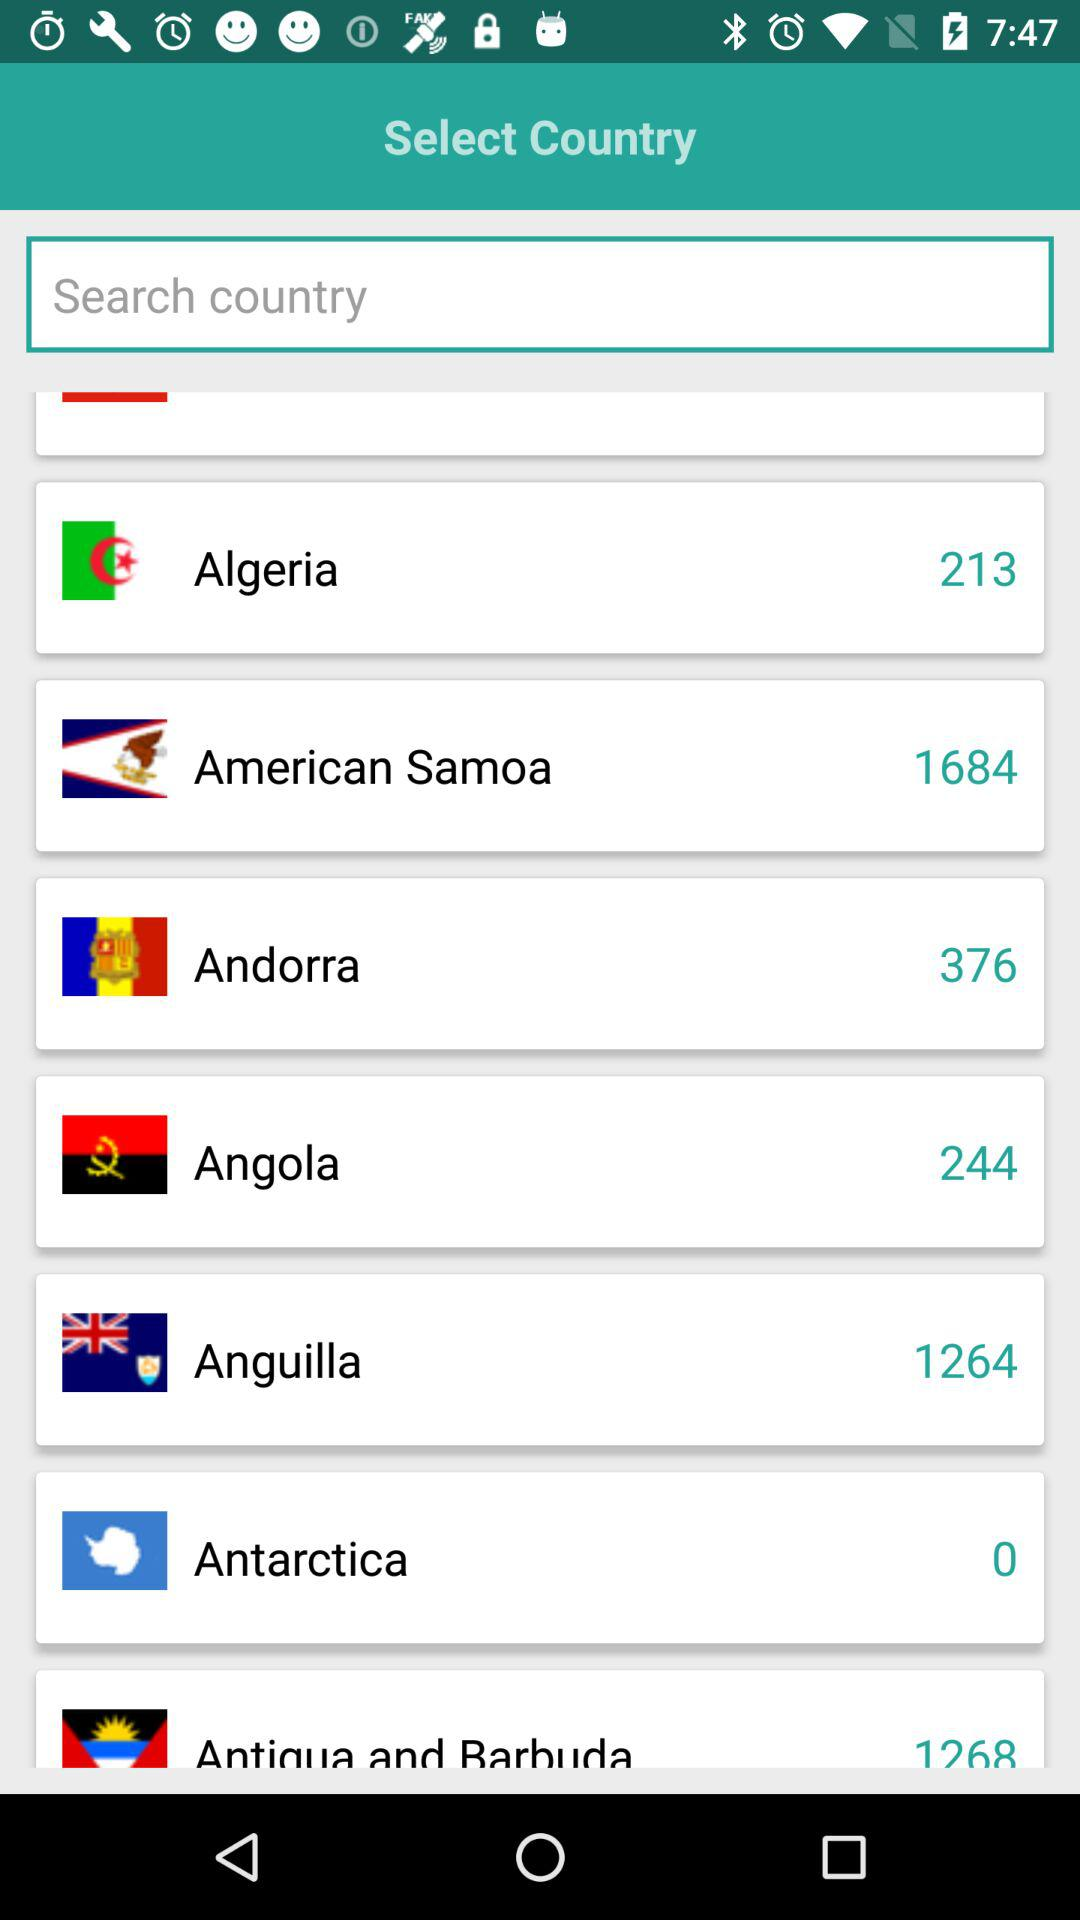Which country is selected?
When the provided information is insufficient, respond with <no answer>. <no answer> 